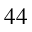<formula> <loc_0><loc_0><loc_500><loc_500>_ { 4 4 }</formula> 